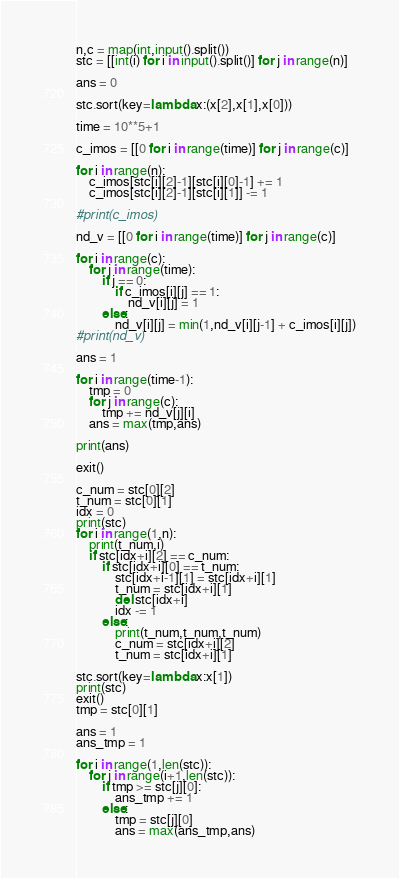Convert code to text. <code><loc_0><loc_0><loc_500><loc_500><_Python_>n,c = map(int,input().split())
stc = [[int(i) for i in input().split()] for j in range(n)]

ans = 0

stc.sort(key=lambda x:(x[2],x[1],x[0]))

time = 10**5+1

c_imos = [[0 for i in range(time)] for j in range(c)]

for i in range(n):
    c_imos[stc[i][2]-1][stc[i][0]-1] += 1
    c_imos[stc[i][2]-1][stc[i][1]] -= 1

#print(c_imos)

nd_v = [[0 for i in range(time)] for j in range(c)]

for i in range(c):
    for j in range(time):
        if j == 0:
            if c_imos[i][j] == 1:
                nd_v[i][j] = 1
        else:
            nd_v[i][j] = min(1,nd_v[i][j-1] + c_imos[i][j])
#print(nd_v)

ans = 1

for i in range(time-1):
    tmp = 0
    for j in range(c):
        tmp += nd_v[j][i]
    ans = max(tmp,ans)

print(ans)

exit()
    
c_num = stc[0][2]
t_num = stc[0][1]
idx = 0
print(stc)
for i in range(1,n):
    print(t_num,i)
    if stc[idx+i][2] == c_num:
        if stc[idx+i][0] == t_num:
            stc[idx+i-1][1] = stc[idx+i][1]
            t_num = stc[idx+i][1]
            del stc[idx+i]
            idx -= 1
        else:
            print(t_num,t_num,t_num)
            c_num = stc[idx+i][2]
            t_num = stc[idx+i][1]

stc.sort(key=lambda x:x[1])
print(stc)
exit()
tmp = stc[0][1]

ans = 1
ans_tmp = 1

for i in range(1,len(stc)):
    for j in range(i+1,len(stc)):
        if tmp >= stc[j][0]:
            ans_tmp += 1
        else:
            tmp = stc[j][0]
            ans = max(ans_tmp,ans)</code> 